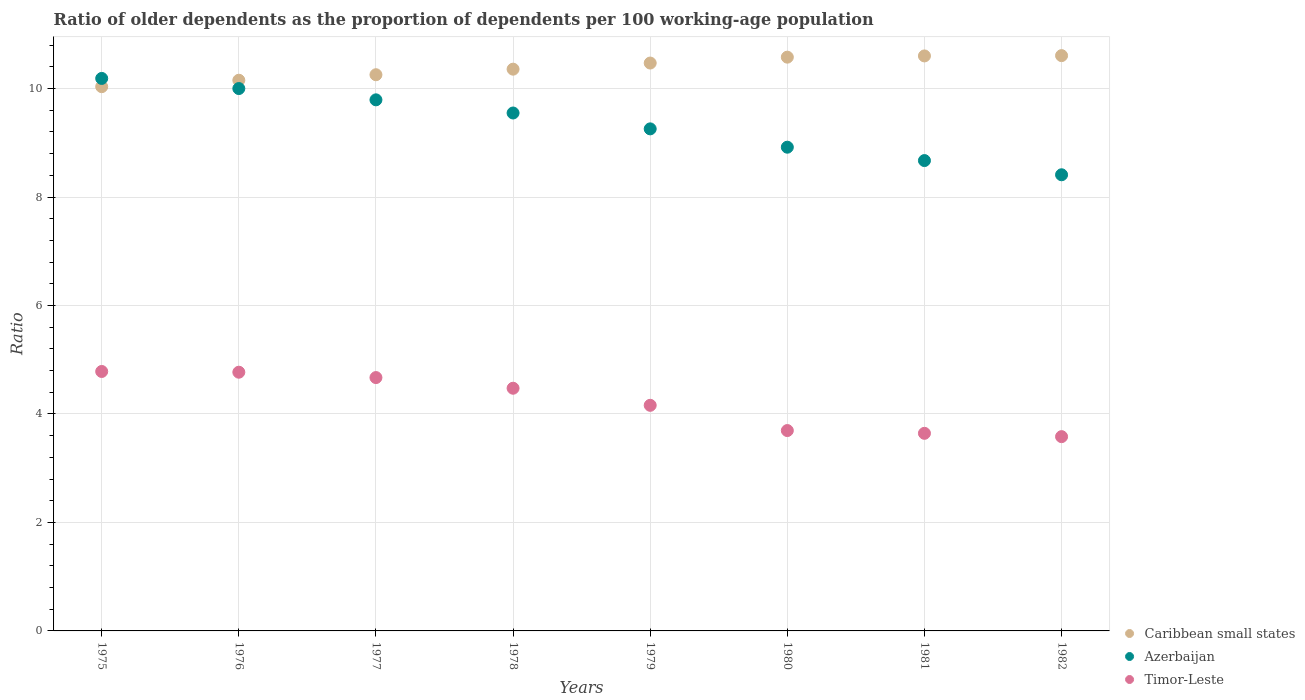What is the age dependency ratio(old) in Azerbaijan in 1975?
Offer a terse response. 10.19. Across all years, what is the maximum age dependency ratio(old) in Azerbaijan?
Ensure brevity in your answer.  10.19. Across all years, what is the minimum age dependency ratio(old) in Timor-Leste?
Make the answer very short. 3.58. In which year was the age dependency ratio(old) in Timor-Leste maximum?
Offer a terse response. 1975. What is the total age dependency ratio(old) in Azerbaijan in the graph?
Make the answer very short. 74.78. What is the difference between the age dependency ratio(old) in Azerbaijan in 1975 and that in 1981?
Keep it short and to the point. 1.51. What is the difference between the age dependency ratio(old) in Timor-Leste in 1979 and the age dependency ratio(old) in Azerbaijan in 1977?
Your response must be concise. -5.63. What is the average age dependency ratio(old) in Caribbean small states per year?
Make the answer very short. 10.38. In the year 1981, what is the difference between the age dependency ratio(old) in Caribbean small states and age dependency ratio(old) in Azerbaijan?
Ensure brevity in your answer.  1.93. What is the ratio of the age dependency ratio(old) in Timor-Leste in 1975 to that in 1976?
Your response must be concise. 1. What is the difference between the highest and the second highest age dependency ratio(old) in Timor-Leste?
Keep it short and to the point. 0.01. What is the difference between the highest and the lowest age dependency ratio(old) in Azerbaijan?
Offer a very short reply. 1.78. Is the sum of the age dependency ratio(old) in Timor-Leste in 1975 and 1977 greater than the maximum age dependency ratio(old) in Azerbaijan across all years?
Provide a short and direct response. No. Is the age dependency ratio(old) in Caribbean small states strictly less than the age dependency ratio(old) in Azerbaijan over the years?
Your answer should be very brief. No. How many years are there in the graph?
Your response must be concise. 8. What is the difference between two consecutive major ticks on the Y-axis?
Offer a terse response. 2. How many legend labels are there?
Your answer should be compact. 3. What is the title of the graph?
Offer a very short reply. Ratio of older dependents as the proportion of dependents per 100 working-age population. What is the label or title of the X-axis?
Offer a terse response. Years. What is the label or title of the Y-axis?
Ensure brevity in your answer.  Ratio. What is the Ratio in Caribbean small states in 1975?
Keep it short and to the point. 10.03. What is the Ratio of Azerbaijan in 1975?
Offer a terse response. 10.19. What is the Ratio in Timor-Leste in 1975?
Provide a succinct answer. 4.78. What is the Ratio of Caribbean small states in 1976?
Your response must be concise. 10.15. What is the Ratio of Azerbaijan in 1976?
Give a very brief answer. 10. What is the Ratio of Timor-Leste in 1976?
Your answer should be very brief. 4.77. What is the Ratio of Caribbean small states in 1977?
Your response must be concise. 10.25. What is the Ratio in Azerbaijan in 1977?
Make the answer very short. 9.79. What is the Ratio in Timor-Leste in 1977?
Keep it short and to the point. 4.67. What is the Ratio of Caribbean small states in 1978?
Give a very brief answer. 10.36. What is the Ratio in Azerbaijan in 1978?
Provide a short and direct response. 9.55. What is the Ratio of Timor-Leste in 1978?
Keep it short and to the point. 4.47. What is the Ratio in Caribbean small states in 1979?
Give a very brief answer. 10.47. What is the Ratio in Azerbaijan in 1979?
Offer a terse response. 9.26. What is the Ratio of Timor-Leste in 1979?
Offer a very short reply. 4.16. What is the Ratio in Caribbean small states in 1980?
Keep it short and to the point. 10.58. What is the Ratio in Azerbaijan in 1980?
Provide a succinct answer. 8.92. What is the Ratio in Timor-Leste in 1980?
Provide a succinct answer. 3.69. What is the Ratio of Caribbean small states in 1981?
Ensure brevity in your answer.  10.6. What is the Ratio in Azerbaijan in 1981?
Give a very brief answer. 8.67. What is the Ratio in Timor-Leste in 1981?
Offer a very short reply. 3.64. What is the Ratio in Caribbean small states in 1982?
Provide a short and direct response. 10.61. What is the Ratio in Azerbaijan in 1982?
Provide a succinct answer. 8.41. What is the Ratio of Timor-Leste in 1982?
Provide a short and direct response. 3.58. Across all years, what is the maximum Ratio of Caribbean small states?
Offer a very short reply. 10.61. Across all years, what is the maximum Ratio in Azerbaijan?
Offer a terse response. 10.19. Across all years, what is the maximum Ratio of Timor-Leste?
Provide a succinct answer. 4.78. Across all years, what is the minimum Ratio of Caribbean small states?
Offer a very short reply. 10.03. Across all years, what is the minimum Ratio in Azerbaijan?
Keep it short and to the point. 8.41. Across all years, what is the minimum Ratio in Timor-Leste?
Ensure brevity in your answer.  3.58. What is the total Ratio of Caribbean small states in the graph?
Your answer should be compact. 83.06. What is the total Ratio of Azerbaijan in the graph?
Give a very brief answer. 74.78. What is the total Ratio in Timor-Leste in the graph?
Your answer should be very brief. 33.78. What is the difference between the Ratio in Caribbean small states in 1975 and that in 1976?
Your answer should be compact. -0.12. What is the difference between the Ratio of Azerbaijan in 1975 and that in 1976?
Ensure brevity in your answer.  0.19. What is the difference between the Ratio of Timor-Leste in 1975 and that in 1976?
Keep it short and to the point. 0.01. What is the difference between the Ratio of Caribbean small states in 1975 and that in 1977?
Offer a very short reply. -0.22. What is the difference between the Ratio of Azerbaijan in 1975 and that in 1977?
Your answer should be very brief. 0.39. What is the difference between the Ratio of Timor-Leste in 1975 and that in 1977?
Keep it short and to the point. 0.11. What is the difference between the Ratio of Caribbean small states in 1975 and that in 1978?
Provide a short and direct response. -0.32. What is the difference between the Ratio of Azerbaijan in 1975 and that in 1978?
Offer a terse response. 0.64. What is the difference between the Ratio of Timor-Leste in 1975 and that in 1978?
Give a very brief answer. 0.31. What is the difference between the Ratio of Caribbean small states in 1975 and that in 1979?
Offer a very short reply. -0.44. What is the difference between the Ratio of Azerbaijan in 1975 and that in 1979?
Your answer should be compact. 0.93. What is the difference between the Ratio in Timor-Leste in 1975 and that in 1979?
Offer a very short reply. 0.62. What is the difference between the Ratio in Caribbean small states in 1975 and that in 1980?
Make the answer very short. -0.54. What is the difference between the Ratio in Azerbaijan in 1975 and that in 1980?
Keep it short and to the point. 1.27. What is the difference between the Ratio in Timor-Leste in 1975 and that in 1980?
Your response must be concise. 1.09. What is the difference between the Ratio of Caribbean small states in 1975 and that in 1981?
Your answer should be very brief. -0.57. What is the difference between the Ratio in Azerbaijan in 1975 and that in 1981?
Provide a short and direct response. 1.51. What is the difference between the Ratio of Timor-Leste in 1975 and that in 1981?
Your response must be concise. 1.14. What is the difference between the Ratio in Caribbean small states in 1975 and that in 1982?
Offer a very short reply. -0.57. What is the difference between the Ratio in Azerbaijan in 1975 and that in 1982?
Offer a very short reply. 1.78. What is the difference between the Ratio of Timor-Leste in 1975 and that in 1982?
Make the answer very short. 1.2. What is the difference between the Ratio in Caribbean small states in 1976 and that in 1977?
Your answer should be compact. -0.1. What is the difference between the Ratio of Azerbaijan in 1976 and that in 1977?
Provide a short and direct response. 0.21. What is the difference between the Ratio in Timor-Leste in 1976 and that in 1977?
Offer a very short reply. 0.1. What is the difference between the Ratio of Caribbean small states in 1976 and that in 1978?
Ensure brevity in your answer.  -0.2. What is the difference between the Ratio of Azerbaijan in 1976 and that in 1978?
Your response must be concise. 0.45. What is the difference between the Ratio in Timor-Leste in 1976 and that in 1978?
Offer a very short reply. 0.3. What is the difference between the Ratio of Caribbean small states in 1976 and that in 1979?
Offer a very short reply. -0.32. What is the difference between the Ratio in Azerbaijan in 1976 and that in 1979?
Your answer should be very brief. 0.74. What is the difference between the Ratio of Timor-Leste in 1976 and that in 1979?
Ensure brevity in your answer.  0.61. What is the difference between the Ratio of Caribbean small states in 1976 and that in 1980?
Provide a short and direct response. -0.43. What is the difference between the Ratio of Azerbaijan in 1976 and that in 1980?
Offer a terse response. 1.08. What is the difference between the Ratio in Timor-Leste in 1976 and that in 1980?
Offer a terse response. 1.08. What is the difference between the Ratio in Caribbean small states in 1976 and that in 1981?
Offer a terse response. -0.45. What is the difference between the Ratio of Azerbaijan in 1976 and that in 1981?
Keep it short and to the point. 1.33. What is the difference between the Ratio of Timor-Leste in 1976 and that in 1981?
Your answer should be very brief. 1.13. What is the difference between the Ratio of Caribbean small states in 1976 and that in 1982?
Provide a short and direct response. -0.45. What is the difference between the Ratio in Azerbaijan in 1976 and that in 1982?
Offer a very short reply. 1.59. What is the difference between the Ratio of Timor-Leste in 1976 and that in 1982?
Offer a terse response. 1.19. What is the difference between the Ratio of Caribbean small states in 1977 and that in 1978?
Offer a very short reply. -0.1. What is the difference between the Ratio in Azerbaijan in 1977 and that in 1978?
Make the answer very short. 0.24. What is the difference between the Ratio in Timor-Leste in 1977 and that in 1978?
Keep it short and to the point. 0.2. What is the difference between the Ratio of Caribbean small states in 1977 and that in 1979?
Offer a terse response. -0.22. What is the difference between the Ratio of Azerbaijan in 1977 and that in 1979?
Provide a short and direct response. 0.54. What is the difference between the Ratio of Timor-Leste in 1977 and that in 1979?
Ensure brevity in your answer.  0.51. What is the difference between the Ratio in Caribbean small states in 1977 and that in 1980?
Offer a very short reply. -0.32. What is the difference between the Ratio in Azerbaijan in 1977 and that in 1980?
Give a very brief answer. 0.87. What is the difference between the Ratio of Timor-Leste in 1977 and that in 1980?
Give a very brief answer. 0.98. What is the difference between the Ratio of Caribbean small states in 1977 and that in 1981?
Your answer should be very brief. -0.35. What is the difference between the Ratio in Azerbaijan in 1977 and that in 1981?
Ensure brevity in your answer.  1.12. What is the difference between the Ratio in Timor-Leste in 1977 and that in 1981?
Provide a short and direct response. 1.03. What is the difference between the Ratio of Caribbean small states in 1977 and that in 1982?
Your answer should be compact. -0.35. What is the difference between the Ratio in Azerbaijan in 1977 and that in 1982?
Your response must be concise. 1.38. What is the difference between the Ratio of Timor-Leste in 1977 and that in 1982?
Provide a succinct answer. 1.09. What is the difference between the Ratio of Caribbean small states in 1978 and that in 1979?
Keep it short and to the point. -0.11. What is the difference between the Ratio of Azerbaijan in 1978 and that in 1979?
Offer a very short reply. 0.29. What is the difference between the Ratio in Timor-Leste in 1978 and that in 1979?
Give a very brief answer. 0.31. What is the difference between the Ratio in Caribbean small states in 1978 and that in 1980?
Give a very brief answer. -0.22. What is the difference between the Ratio in Azerbaijan in 1978 and that in 1980?
Make the answer very short. 0.63. What is the difference between the Ratio of Timor-Leste in 1978 and that in 1980?
Your answer should be very brief. 0.78. What is the difference between the Ratio of Caribbean small states in 1978 and that in 1981?
Offer a very short reply. -0.24. What is the difference between the Ratio in Azerbaijan in 1978 and that in 1981?
Your answer should be compact. 0.88. What is the difference between the Ratio of Timor-Leste in 1978 and that in 1981?
Offer a terse response. 0.83. What is the difference between the Ratio of Caribbean small states in 1978 and that in 1982?
Make the answer very short. -0.25. What is the difference between the Ratio in Azerbaijan in 1978 and that in 1982?
Your answer should be very brief. 1.14. What is the difference between the Ratio in Timor-Leste in 1978 and that in 1982?
Provide a succinct answer. 0.89. What is the difference between the Ratio of Caribbean small states in 1979 and that in 1980?
Make the answer very short. -0.11. What is the difference between the Ratio in Azerbaijan in 1979 and that in 1980?
Your answer should be compact. 0.34. What is the difference between the Ratio of Timor-Leste in 1979 and that in 1980?
Your answer should be very brief. 0.47. What is the difference between the Ratio in Caribbean small states in 1979 and that in 1981?
Offer a terse response. -0.13. What is the difference between the Ratio in Azerbaijan in 1979 and that in 1981?
Your answer should be very brief. 0.58. What is the difference between the Ratio of Timor-Leste in 1979 and that in 1981?
Make the answer very short. 0.52. What is the difference between the Ratio of Caribbean small states in 1979 and that in 1982?
Ensure brevity in your answer.  -0.14. What is the difference between the Ratio of Azerbaijan in 1979 and that in 1982?
Ensure brevity in your answer.  0.85. What is the difference between the Ratio in Timor-Leste in 1979 and that in 1982?
Give a very brief answer. 0.58. What is the difference between the Ratio in Caribbean small states in 1980 and that in 1981?
Your response must be concise. -0.02. What is the difference between the Ratio in Azerbaijan in 1980 and that in 1981?
Provide a succinct answer. 0.25. What is the difference between the Ratio in Timor-Leste in 1980 and that in 1981?
Provide a succinct answer. 0.05. What is the difference between the Ratio in Caribbean small states in 1980 and that in 1982?
Your answer should be very brief. -0.03. What is the difference between the Ratio in Azerbaijan in 1980 and that in 1982?
Your response must be concise. 0.51. What is the difference between the Ratio in Timor-Leste in 1980 and that in 1982?
Your answer should be very brief. 0.11. What is the difference between the Ratio in Caribbean small states in 1981 and that in 1982?
Provide a short and direct response. -0.01. What is the difference between the Ratio in Azerbaijan in 1981 and that in 1982?
Ensure brevity in your answer.  0.26. What is the difference between the Ratio in Timor-Leste in 1981 and that in 1982?
Make the answer very short. 0.06. What is the difference between the Ratio of Caribbean small states in 1975 and the Ratio of Azerbaijan in 1976?
Your response must be concise. 0.03. What is the difference between the Ratio of Caribbean small states in 1975 and the Ratio of Timor-Leste in 1976?
Provide a succinct answer. 5.26. What is the difference between the Ratio in Azerbaijan in 1975 and the Ratio in Timor-Leste in 1976?
Ensure brevity in your answer.  5.42. What is the difference between the Ratio of Caribbean small states in 1975 and the Ratio of Azerbaijan in 1977?
Your response must be concise. 0.24. What is the difference between the Ratio of Caribbean small states in 1975 and the Ratio of Timor-Leste in 1977?
Provide a short and direct response. 5.36. What is the difference between the Ratio in Azerbaijan in 1975 and the Ratio in Timor-Leste in 1977?
Make the answer very short. 5.52. What is the difference between the Ratio in Caribbean small states in 1975 and the Ratio in Azerbaijan in 1978?
Offer a terse response. 0.49. What is the difference between the Ratio of Caribbean small states in 1975 and the Ratio of Timor-Leste in 1978?
Keep it short and to the point. 5.56. What is the difference between the Ratio in Azerbaijan in 1975 and the Ratio in Timor-Leste in 1978?
Offer a terse response. 5.71. What is the difference between the Ratio of Caribbean small states in 1975 and the Ratio of Azerbaijan in 1979?
Keep it short and to the point. 0.78. What is the difference between the Ratio of Caribbean small states in 1975 and the Ratio of Timor-Leste in 1979?
Make the answer very short. 5.87. What is the difference between the Ratio in Azerbaijan in 1975 and the Ratio in Timor-Leste in 1979?
Provide a succinct answer. 6.03. What is the difference between the Ratio in Caribbean small states in 1975 and the Ratio in Azerbaijan in 1980?
Provide a short and direct response. 1.12. What is the difference between the Ratio of Caribbean small states in 1975 and the Ratio of Timor-Leste in 1980?
Offer a terse response. 6.34. What is the difference between the Ratio of Azerbaijan in 1975 and the Ratio of Timor-Leste in 1980?
Give a very brief answer. 6.49. What is the difference between the Ratio of Caribbean small states in 1975 and the Ratio of Azerbaijan in 1981?
Your answer should be very brief. 1.36. What is the difference between the Ratio of Caribbean small states in 1975 and the Ratio of Timor-Leste in 1981?
Keep it short and to the point. 6.39. What is the difference between the Ratio in Azerbaijan in 1975 and the Ratio in Timor-Leste in 1981?
Keep it short and to the point. 6.54. What is the difference between the Ratio of Caribbean small states in 1975 and the Ratio of Azerbaijan in 1982?
Provide a short and direct response. 1.62. What is the difference between the Ratio in Caribbean small states in 1975 and the Ratio in Timor-Leste in 1982?
Ensure brevity in your answer.  6.45. What is the difference between the Ratio in Azerbaijan in 1975 and the Ratio in Timor-Leste in 1982?
Make the answer very short. 6.6. What is the difference between the Ratio of Caribbean small states in 1976 and the Ratio of Azerbaijan in 1977?
Provide a succinct answer. 0.36. What is the difference between the Ratio in Caribbean small states in 1976 and the Ratio in Timor-Leste in 1977?
Provide a succinct answer. 5.48. What is the difference between the Ratio in Azerbaijan in 1976 and the Ratio in Timor-Leste in 1977?
Your answer should be compact. 5.33. What is the difference between the Ratio in Caribbean small states in 1976 and the Ratio in Azerbaijan in 1978?
Your response must be concise. 0.6. What is the difference between the Ratio of Caribbean small states in 1976 and the Ratio of Timor-Leste in 1978?
Your response must be concise. 5.68. What is the difference between the Ratio in Azerbaijan in 1976 and the Ratio in Timor-Leste in 1978?
Give a very brief answer. 5.53. What is the difference between the Ratio in Caribbean small states in 1976 and the Ratio in Azerbaijan in 1979?
Make the answer very short. 0.9. What is the difference between the Ratio of Caribbean small states in 1976 and the Ratio of Timor-Leste in 1979?
Your answer should be compact. 5.99. What is the difference between the Ratio in Azerbaijan in 1976 and the Ratio in Timor-Leste in 1979?
Make the answer very short. 5.84. What is the difference between the Ratio of Caribbean small states in 1976 and the Ratio of Azerbaijan in 1980?
Give a very brief answer. 1.23. What is the difference between the Ratio of Caribbean small states in 1976 and the Ratio of Timor-Leste in 1980?
Provide a short and direct response. 6.46. What is the difference between the Ratio of Azerbaijan in 1976 and the Ratio of Timor-Leste in 1980?
Your response must be concise. 6.31. What is the difference between the Ratio in Caribbean small states in 1976 and the Ratio in Azerbaijan in 1981?
Ensure brevity in your answer.  1.48. What is the difference between the Ratio of Caribbean small states in 1976 and the Ratio of Timor-Leste in 1981?
Make the answer very short. 6.51. What is the difference between the Ratio of Azerbaijan in 1976 and the Ratio of Timor-Leste in 1981?
Your response must be concise. 6.36. What is the difference between the Ratio of Caribbean small states in 1976 and the Ratio of Azerbaijan in 1982?
Provide a short and direct response. 1.74. What is the difference between the Ratio in Caribbean small states in 1976 and the Ratio in Timor-Leste in 1982?
Give a very brief answer. 6.57. What is the difference between the Ratio in Azerbaijan in 1976 and the Ratio in Timor-Leste in 1982?
Provide a succinct answer. 6.42. What is the difference between the Ratio of Caribbean small states in 1977 and the Ratio of Azerbaijan in 1978?
Your answer should be compact. 0.71. What is the difference between the Ratio in Caribbean small states in 1977 and the Ratio in Timor-Leste in 1978?
Your response must be concise. 5.78. What is the difference between the Ratio in Azerbaijan in 1977 and the Ratio in Timor-Leste in 1978?
Offer a terse response. 5.32. What is the difference between the Ratio in Caribbean small states in 1977 and the Ratio in Azerbaijan in 1979?
Your response must be concise. 1. What is the difference between the Ratio of Caribbean small states in 1977 and the Ratio of Timor-Leste in 1979?
Offer a very short reply. 6.1. What is the difference between the Ratio of Azerbaijan in 1977 and the Ratio of Timor-Leste in 1979?
Keep it short and to the point. 5.63. What is the difference between the Ratio of Caribbean small states in 1977 and the Ratio of Azerbaijan in 1980?
Ensure brevity in your answer.  1.34. What is the difference between the Ratio in Caribbean small states in 1977 and the Ratio in Timor-Leste in 1980?
Keep it short and to the point. 6.56. What is the difference between the Ratio of Azerbaijan in 1977 and the Ratio of Timor-Leste in 1980?
Your answer should be compact. 6.1. What is the difference between the Ratio of Caribbean small states in 1977 and the Ratio of Azerbaijan in 1981?
Offer a terse response. 1.58. What is the difference between the Ratio of Caribbean small states in 1977 and the Ratio of Timor-Leste in 1981?
Your answer should be compact. 6.61. What is the difference between the Ratio of Azerbaijan in 1977 and the Ratio of Timor-Leste in 1981?
Provide a succinct answer. 6.15. What is the difference between the Ratio of Caribbean small states in 1977 and the Ratio of Azerbaijan in 1982?
Offer a terse response. 1.84. What is the difference between the Ratio in Caribbean small states in 1977 and the Ratio in Timor-Leste in 1982?
Keep it short and to the point. 6.67. What is the difference between the Ratio in Azerbaijan in 1977 and the Ratio in Timor-Leste in 1982?
Offer a terse response. 6.21. What is the difference between the Ratio in Caribbean small states in 1978 and the Ratio in Azerbaijan in 1979?
Your answer should be very brief. 1.1. What is the difference between the Ratio in Caribbean small states in 1978 and the Ratio in Timor-Leste in 1979?
Provide a succinct answer. 6.2. What is the difference between the Ratio in Azerbaijan in 1978 and the Ratio in Timor-Leste in 1979?
Provide a short and direct response. 5.39. What is the difference between the Ratio of Caribbean small states in 1978 and the Ratio of Azerbaijan in 1980?
Your answer should be very brief. 1.44. What is the difference between the Ratio of Caribbean small states in 1978 and the Ratio of Timor-Leste in 1980?
Keep it short and to the point. 6.66. What is the difference between the Ratio in Azerbaijan in 1978 and the Ratio in Timor-Leste in 1980?
Ensure brevity in your answer.  5.85. What is the difference between the Ratio in Caribbean small states in 1978 and the Ratio in Azerbaijan in 1981?
Provide a succinct answer. 1.69. What is the difference between the Ratio of Caribbean small states in 1978 and the Ratio of Timor-Leste in 1981?
Offer a very short reply. 6.71. What is the difference between the Ratio of Azerbaijan in 1978 and the Ratio of Timor-Leste in 1981?
Ensure brevity in your answer.  5.91. What is the difference between the Ratio of Caribbean small states in 1978 and the Ratio of Azerbaijan in 1982?
Your answer should be very brief. 1.95. What is the difference between the Ratio in Caribbean small states in 1978 and the Ratio in Timor-Leste in 1982?
Give a very brief answer. 6.78. What is the difference between the Ratio of Azerbaijan in 1978 and the Ratio of Timor-Leste in 1982?
Offer a terse response. 5.97. What is the difference between the Ratio in Caribbean small states in 1979 and the Ratio in Azerbaijan in 1980?
Offer a very short reply. 1.55. What is the difference between the Ratio of Caribbean small states in 1979 and the Ratio of Timor-Leste in 1980?
Your answer should be compact. 6.78. What is the difference between the Ratio in Azerbaijan in 1979 and the Ratio in Timor-Leste in 1980?
Ensure brevity in your answer.  5.56. What is the difference between the Ratio of Caribbean small states in 1979 and the Ratio of Azerbaijan in 1981?
Provide a short and direct response. 1.8. What is the difference between the Ratio in Caribbean small states in 1979 and the Ratio in Timor-Leste in 1981?
Give a very brief answer. 6.83. What is the difference between the Ratio of Azerbaijan in 1979 and the Ratio of Timor-Leste in 1981?
Your answer should be compact. 5.61. What is the difference between the Ratio in Caribbean small states in 1979 and the Ratio in Azerbaijan in 1982?
Your answer should be compact. 2.06. What is the difference between the Ratio of Caribbean small states in 1979 and the Ratio of Timor-Leste in 1982?
Your answer should be compact. 6.89. What is the difference between the Ratio in Azerbaijan in 1979 and the Ratio in Timor-Leste in 1982?
Give a very brief answer. 5.67. What is the difference between the Ratio in Caribbean small states in 1980 and the Ratio in Azerbaijan in 1981?
Give a very brief answer. 1.91. What is the difference between the Ratio of Caribbean small states in 1980 and the Ratio of Timor-Leste in 1981?
Ensure brevity in your answer.  6.94. What is the difference between the Ratio of Azerbaijan in 1980 and the Ratio of Timor-Leste in 1981?
Make the answer very short. 5.28. What is the difference between the Ratio of Caribbean small states in 1980 and the Ratio of Azerbaijan in 1982?
Your answer should be very brief. 2.17. What is the difference between the Ratio of Caribbean small states in 1980 and the Ratio of Timor-Leste in 1982?
Keep it short and to the point. 7. What is the difference between the Ratio of Azerbaijan in 1980 and the Ratio of Timor-Leste in 1982?
Your answer should be very brief. 5.34. What is the difference between the Ratio of Caribbean small states in 1981 and the Ratio of Azerbaijan in 1982?
Keep it short and to the point. 2.19. What is the difference between the Ratio in Caribbean small states in 1981 and the Ratio in Timor-Leste in 1982?
Your response must be concise. 7.02. What is the difference between the Ratio of Azerbaijan in 1981 and the Ratio of Timor-Leste in 1982?
Your answer should be very brief. 5.09. What is the average Ratio in Caribbean small states per year?
Give a very brief answer. 10.38. What is the average Ratio in Azerbaijan per year?
Offer a terse response. 9.35. What is the average Ratio of Timor-Leste per year?
Offer a very short reply. 4.22. In the year 1975, what is the difference between the Ratio in Caribbean small states and Ratio in Azerbaijan?
Offer a very short reply. -0.15. In the year 1975, what is the difference between the Ratio in Caribbean small states and Ratio in Timor-Leste?
Your answer should be compact. 5.25. In the year 1975, what is the difference between the Ratio in Azerbaijan and Ratio in Timor-Leste?
Provide a succinct answer. 5.4. In the year 1976, what is the difference between the Ratio in Caribbean small states and Ratio in Azerbaijan?
Ensure brevity in your answer.  0.15. In the year 1976, what is the difference between the Ratio in Caribbean small states and Ratio in Timor-Leste?
Give a very brief answer. 5.38. In the year 1976, what is the difference between the Ratio in Azerbaijan and Ratio in Timor-Leste?
Ensure brevity in your answer.  5.23. In the year 1977, what is the difference between the Ratio of Caribbean small states and Ratio of Azerbaijan?
Provide a short and direct response. 0.46. In the year 1977, what is the difference between the Ratio of Caribbean small states and Ratio of Timor-Leste?
Provide a succinct answer. 5.58. In the year 1977, what is the difference between the Ratio of Azerbaijan and Ratio of Timor-Leste?
Your response must be concise. 5.12. In the year 1978, what is the difference between the Ratio in Caribbean small states and Ratio in Azerbaijan?
Offer a very short reply. 0.81. In the year 1978, what is the difference between the Ratio of Caribbean small states and Ratio of Timor-Leste?
Offer a very short reply. 5.88. In the year 1978, what is the difference between the Ratio of Azerbaijan and Ratio of Timor-Leste?
Give a very brief answer. 5.07. In the year 1979, what is the difference between the Ratio of Caribbean small states and Ratio of Azerbaijan?
Offer a terse response. 1.21. In the year 1979, what is the difference between the Ratio in Caribbean small states and Ratio in Timor-Leste?
Keep it short and to the point. 6.31. In the year 1979, what is the difference between the Ratio in Azerbaijan and Ratio in Timor-Leste?
Give a very brief answer. 5.1. In the year 1980, what is the difference between the Ratio of Caribbean small states and Ratio of Azerbaijan?
Make the answer very short. 1.66. In the year 1980, what is the difference between the Ratio of Caribbean small states and Ratio of Timor-Leste?
Offer a very short reply. 6.88. In the year 1980, what is the difference between the Ratio of Azerbaijan and Ratio of Timor-Leste?
Offer a very short reply. 5.22. In the year 1981, what is the difference between the Ratio of Caribbean small states and Ratio of Azerbaijan?
Your answer should be compact. 1.93. In the year 1981, what is the difference between the Ratio of Caribbean small states and Ratio of Timor-Leste?
Your answer should be very brief. 6.96. In the year 1981, what is the difference between the Ratio of Azerbaijan and Ratio of Timor-Leste?
Provide a succinct answer. 5.03. In the year 1982, what is the difference between the Ratio in Caribbean small states and Ratio in Azerbaijan?
Your response must be concise. 2.2. In the year 1982, what is the difference between the Ratio in Caribbean small states and Ratio in Timor-Leste?
Ensure brevity in your answer.  7.03. In the year 1982, what is the difference between the Ratio in Azerbaijan and Ratio in Timor-Leste?
Make the answer very short. 4.83. What is the ratio of the Ratio in Caribbean small states in 1975 to that in 1976?
Offer a terse response. 0.99. What is the ratio of the Ratio in Azerbaijan in 1975 to that in 1976?
Provide a succinct answer. 1.02. What is the ratio of the Ratio of Timor-Leste in 1975 to that in 1976?
Your response must be concise. 1. What is the ratio of the Ratio in Caribbean small states in 1975 to that in 1977?
Offer a very short reply. 0.98. What is the ratio of the Ratio in Azerbaijan in 1975 to that in 1977?
Your answer should be very brief. 1.04. What is the ratio of the Ratio in Timor-Leste in 1975 to that in 1977?
Your answer should be compact. 1.02. What is the ratio of the Ratio in Caribbean small states in 1975 to that in 1978?
Offer a terse response. 0.97. What is the ratio of the Ratio of Azerbaijan in 1975 to that in 1978?
Your answer should be very brief. 1.07. What is the ratio of the Ratio in Timor-Leste in 1975 to that in 1978?
Your answer should be compact. 1.07. What is the ratio of the Ratio in Caribbean small states in 1975 to that in 1979?
Provide a succinct answer. 0.96. What is the ratio of the Ratio in Azerbaijan in 1975 to that in 1979?
Your response must be concise. 1.1. What is the ratio of the Ratio of Timor-Leste in 1975 to that in 1979?
Your answer should be compact. 1.15. What is the ratio of the Ratio in Caribbean small states in 1975 to that in 1980?
Your answer should be compact. 0.95. What is the ratio of the Ratio of Azerbaijan in 1975 to that in 1980?
Keep it short and to the point. 1.14. What is the ratio of the Ratio in Timor-Leste in 1975 to that in 1980?
Give a very brief answer. 1.29. What is the ratio of the Ratio in Caribbean small states in 1975 to that in 1981?
Provide a succinct answer. 0.95. What is the ratio of the Ratio in Azerbaijan in 1975 to that in 1981?
Offer a terse response. 1.17. What is the ratio of the Ratio in Timor-Leste in 1975 to that in 1981?
Offer a terse response. 1.31. What is the ratio of the Ratio of Caribbean small states in 1975 to that in 1982?
Offer a very short reply. 0.95. What is the ratio of the Ratio of Azerbaijan in 1975 to that in 1982?
Offer a very short reply. 1.21. What is the ratio of the Ratio of Timor-Leste in 1975 to that in 1982?
Your answer should be very brief. 1.34. What is the ratio of the Ratio in Azerbaijan in 1976 to that in 1977?
Offer a terse response. 1.02. What is the ratio of the Ratio in Timor-Leste in 1976 to that in 1977?
Give a very brief answer. 1.02. What is the ratio of the Ratio of Caribbean small states in 1976 to that in 1978?
Your answer should be very brief. 0.98. What is the ratio of the Ratio of Azerbaijan in 1976 to that in 1978?
Offer a very short reply. 1.05. What is the ratio of the Ratio of Timor-Leste in 1976 to that in 1978?
Offer a terse response. 1.07. What is the ratio of the Ratio in Caribbean small states in 1976 to that in 1979?
Provide a succinct answer. 0.97. What is the ratio of the Ratio of Azerbaijan in 1976 to that in 1979?
Provide a succinct answer. 1.08. What is the ratio of the Ratio of Timor-Leste in 1976 to that in 1979?
Offer a terse response. 1.15. What is the ratio of the Ratio in Caribbean small states in 1976 to that in 1980?
Keep it short and to the point. 0.96. What is the ratio of the Ratio of Azerbaijan in 1976 to that in 1980?
Give a very brief answer. 1.12. What is the ratio of the Ratio in Timor-Leste in 1976 to that in 1980?
Provide a short and direct response. 1.29. What is the ratio of the Ratio in Caribbean small states in 1976 to that in 1981?
Offer a very short reply. 0.96. What is the ratio of the Ratio of Azerbaijan in 1976 to that in 1981?
Offer a terse response. 1.15. What is the ratio of the Ratio of Timor-Leste in 1976 to that in 1981?
Offer a very short reply. 1.31. What is the ratio of the Ratio in Caribbean small states in 1976 to that in 1982?
Make the answer very short. 0.96. What is the ratio of the Ratio in Azerbaijan in 1976 to that in 1982?
Ensure brevity in your answer.  1.19. What is the ratio of the Ratio in Timor-Leste in 1976 to that in 1982?
Keep it short and to the point. 1.33. What is the ratio of the Ratio in Caribbean small states in 1977 to that in 1978?
Provide a succinct answer. 0.99. What is the ratio of the Ratio in Azerbaijan in 1977 to that in 1978?
Make the answer very short. 1.03. What is the ratio of the Ratio in Timor-Leste in 1977 to that in 1978?
Provide a succinct answer. 1.04. What is the ratio of the Ratio of Caribbean small states in 1977 to that in 1979?
Your answer should be very brief. 0.98. What is the ratio of the Ratio in Azerbaijan in 1977 to that in 1979?
Give a very brief answer. 1.06. What is the ratio of the Ratio of Timor-Leste in 1977 to that in 1979?
Give a very brief answer. 1.12. What is the ratio of the Ratio of Caribbean small states in 1977 to that in 1980?
Ensure brevity in your answer.  0.97. What is the ratio of the Ratio of Azerbaijan in 1977 to that in 1980?
Your answer should be compact. 1.1. What is the ratio of the Ratio in Timor-Leste in 1977 to that in 1980?
Ensure brevity in your answer.  1.26. What is the ratio of the Ratio of Caribbean small states in 1977 to that in 1981?
Offer a terse response. 0.97. What is the ratio of the Ratio in Azerbaijan in 1977 to that in 1981?
Your answer should be very brief. 1.13. What is the ratio of the Ratio in Timor-Leste in 1977 to that in 1981?
Ensure brevity in your answer.  1.28. What is the ratio of the Ratio in Caribbean small states in 1977 to that in 1982?
Your response must be concise. 0.97. What is the ratio of the Ratio in Azerbaijan in 1977 to that in 1982?
Your response must be concise. 1.16. What is the ratio of the Ratio of Timor-Leste in 1977 to that in 1982?
Provide a short and direct response. 1.3. What is the ratio of the Ratio in Caribbean small states in 1978 to that in 1979?
Provide a succinct answer. 0.99. What is the ratio of the Ratio of Azerbaijan in 1978 to that in 1979?
Offer a terse response. 1.03. What is the ratio of the Ratio in Timor-Leste in 1978 to that in 1979?
Provide a short and direct response. 1.08. What is the ratio of the Ratio in Caribbean small states in 1978 to that in 1980?
Keep it short and to the point. 0.98. What is the ratio of the Ratio in Azerbaijan in 1978 to that in 1980?
Ensure brevity in your answer.  1.07. What is the ratio of the Ratio in Timor-Leste in 1978 to that in 1980?
Your response must be concise. 1.21. What is the ratio of the Ratio in Azerbaijan in 1978 to that in 1981?
Provide a succinct answer. 1.1. What is the ratio of the Ratio in Timor-Leste in 1978 to that in 1981?
Provide a short and direct response. 1.23. What is the ratio of the Ratio of Caribbean small states in 1978 to that in 1982?
Your answer should be compact. 0.98. What is the ratio of the Ratio of Azerbaijan in 1978 to that in 1982?
Give a very brief answer. 1.14. What is the ratio of the Ratio in Timor-Leste in 1978 to that in 1982?
Provide a short and direct response. 1.25. What is the ratio of the Ratio of Caribbean small states in 1979 to that in 1980?
Provide a short and direct response. 0.99. What is the ratio of the Ratio of Azerbaijan in 1979 to that in 1980?
Offer a terse response. 1.04. What is the ratio of the Ratio of Timor-Leste in 1979 to that in 1980?
Ensure brevity in your answer.  1.13. What is the ratio of the Ratio in Caribbean small states in 1979 to that in 1981?
Provide a short and direct response. 0.99. What is the ratio of the Ratio of Azerbaijan in 1979 to that in 1981?
Ensure brevity in your answer.  1.07. What is the ratio of the Ratio in Timor-Leste in 1979 to that in 1981?
Make the answer very short. 1.14. What is the ratio of the Ratio in Caribbean small states in 1979 to that in 1982?
Make the answer very short. 0.99. What is the ratio of the Ratio in Azerbaijan in 1979 to that in 1982?
Offer a very short reply. 1.1. What is the ratio of the Ratio of Timor-Leste in 1979 to that in 1982?
Keep it short and to the point. 1.16. What is the ratio of the Ratio of Caribbean small states in 1980 to that in 1981?
Keep it short and to the point. 1. What is the ratio of the Ratio in Azerbaijan in 1980 to that in 1981?
Make the answer very short. 1.03. What is the ratio of the Ratio of Timor-Leste in 1980 to that in 1981?
Your response must be concise. 1.01. What is the ratio of the Ratio in Caribbean small states in 1980 to that in 1982?
Provide a succinct answer. 1. What is the ratio of the Ratio of Azerbaijan in 1980 to that in 1982?
Your answer should be very brief. 1.06. What is the ratio of the Ratio in Timor-Leste in 1980 to that in 1982?
Your response must be concise. 1.03. What is the ratio of the Ratio of Caribbean small states in 1981 to that in 1982?
Give a very brief answer. 1. What is the ratio of the Ratio of Azerbaijan in 1981 to that in 1982?
Provide a succinct answer. 1.03. What is the ratio of the Ratio of Timor-Leste in 1981 to that in 1982?
Your response must be concise. 1.02. What is the difference between the highest and the second highest Ratio of Caribbean small states?
Your answer should be compact. 0.01. What is the difference between the highest and the second highest Ratio in Azerbaijan?
Make the answer very short. 0.19. What is the difference between the highest and the second highest Ratio of Timor-Leste?
Your answer should be very brief. 0.01. What is the difference between the highest and the lowest Ratio of Caribbean small states?
Give a very brief answer. 0.57. What is the difference between the highest and the lowest Ratio of Azerbaijan?
Keep it short and to the point. 1.78. What is the difference between the highest and the lowest Ratio in Timor-Leste?
Offer a very short reply. 1.2. 